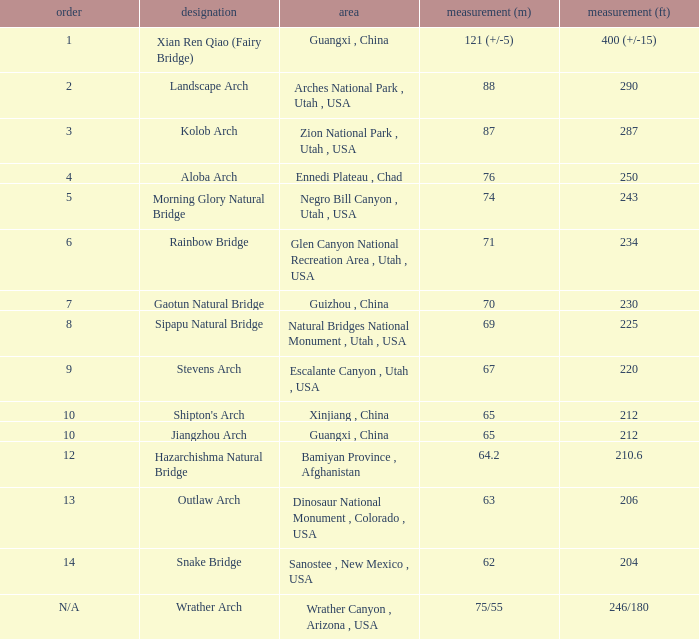What is the length in feet of the Jiangzhou arch? 212.0. 